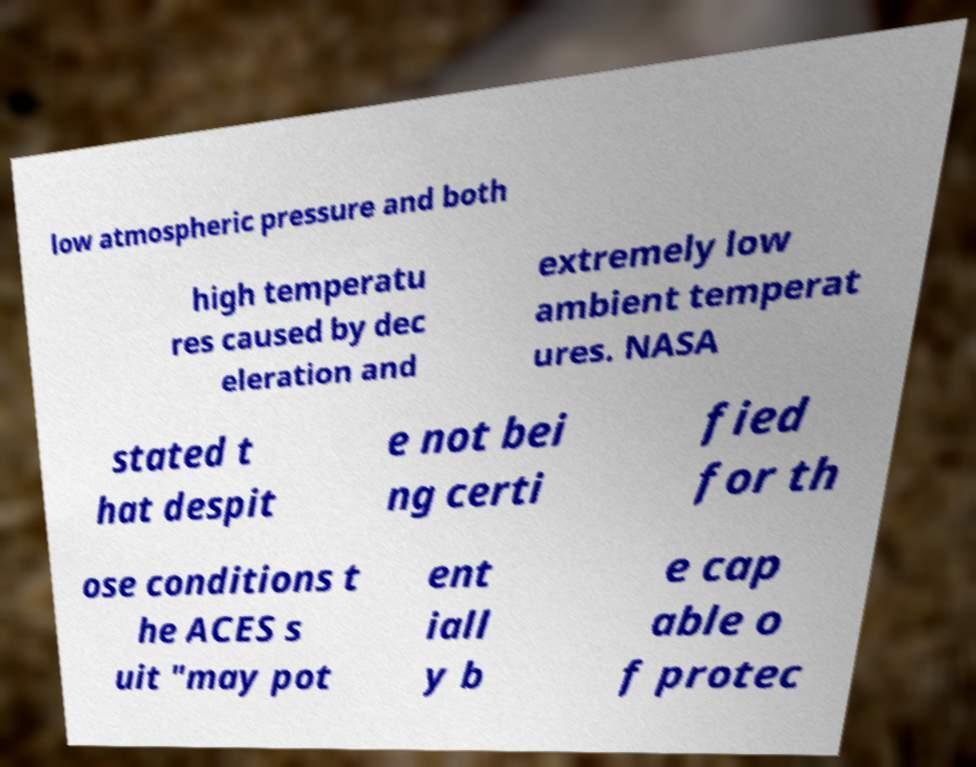I need the written content from this picture converted into text. Can you do that? low atmospheric pressure and both high temperatu res caused by dec eleration and extremely low ambient temperat ures. NASA stated t hat despit e not bei ng certi fied for th ose conditions t he ACES s uit "may pot ent iall y b e cap able o f protec 